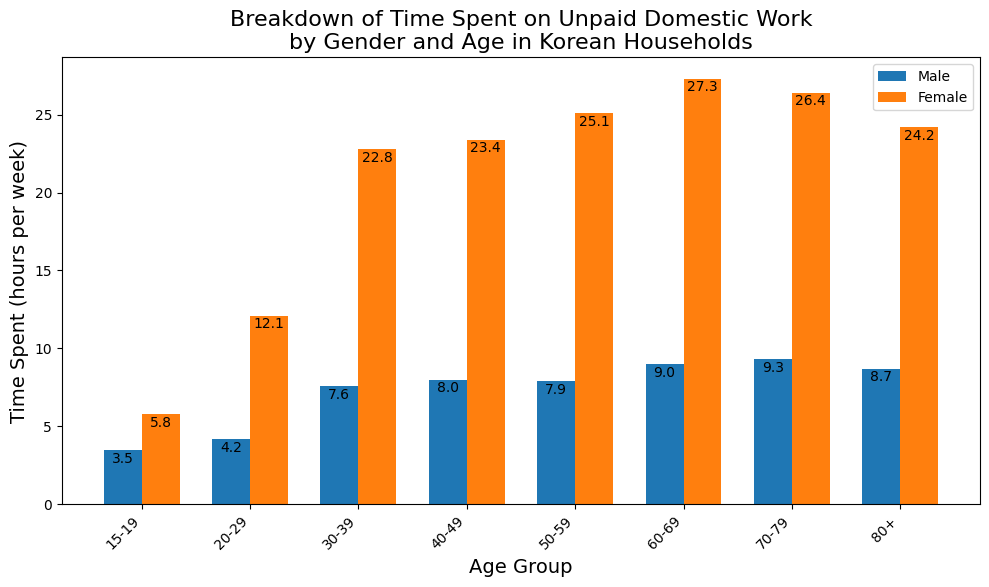What is the average time spent on unpaid domestic work by females across all age groups? To find the average time spent, sum the time spent by females for each age group: 5.8 + 12.1 + 22.8 + 23.4 + 25.1 + 27.3 + 26.4 + 24.2 = 167.1, then divide by the number of age groups (8). The average time spent is 167.1 / 8
Answer: 20.9 Which gender spends more time on unpaid domestic work in the 30-39 age group? Observing the bars for the 30-39 age group, the female bar is much taller than the male bar, indicating that females spend more time on unpaid domestic work.
Answer: Female By how many hours per week do females in the 60-69 age group spend more time on unpaid domestic work than males in the same age group? Subtract the time spent by males (9.0 hours) from the time spent by females (27.3 hours): 27.3 - 9.0 = 18.3 hours
Answer: 18.3 How does the time spent on unpaid domestic work by males in the 50-59 age group compare to females in the 20-29 age group? Comparing the heights of the bars, males in the 50-59 age group spend 7.9 hours per week, while females in the 20-29 age group spend 12.1 hours per week. Thus, females in the 20-29 age group spend more time.
Answer: Females spend more What is the total time spent on unpaid domestic work by males in the 70-79 and 80+ age groups combined? Sum the time spent by males in the 70-79 age group (9.3 hours) and the 80+ age group (8.7 hours): 9.3 + 8.7 = 18.0 hours
Answer: 18.0 hours How much more time do females in the 40-49 age group spend on unpaid domestic work compared to males in the 40-49 age group? Subtract the time spent by males (8.0 hours) from the time spent by females (23.4 hours): 23.4 - 8.0 = 15.4 hours
Answer: 15.4 hours Which age group shows the smallest difference in time spent on unpaid domestic work between males and females? By examining the bar heights for each gender within each age group, the 15-19 age group shows the smallest difference: females spend 5.8 hours and males spend 3.5 hours, with a difference of 2.3 hours.
Answer: 15-19 What is the median time spent on unpaid domestic work by females? To find the median, order the female time values: 5.8, 12.1, 22.8, 23.4, 24.2, 25.1, 26.4, 27.3. The median is the average of the middle two values: (23.4 + 24.2) / 2 = 23.8 hours
Answer: 23.8 hours 